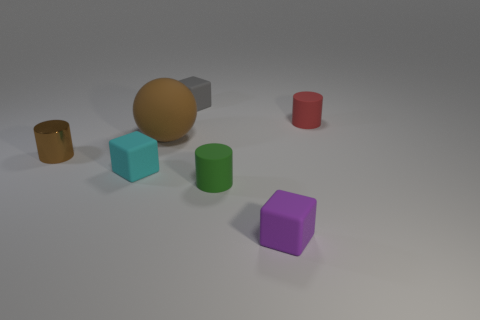Add 2 small brown things. How many objects exist? 9 Subtract all balls. How many objects are left? 6 Subtract 0 yellow cylinders. How many objects are left? 7 Subtract all large gray rubber spheres. Subtract all tiny rubber cylinders. How many objects are left? 5 Add 1 tiny matte cubes. How many tiny matte cubes are left? 4 Add 1 tiny gray cylinders. How many tiny gray cylinders exist? 1 